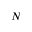Convert formula to latex. <formula><loc_0><loc_0><loc_500><loc_500>N</formula> 